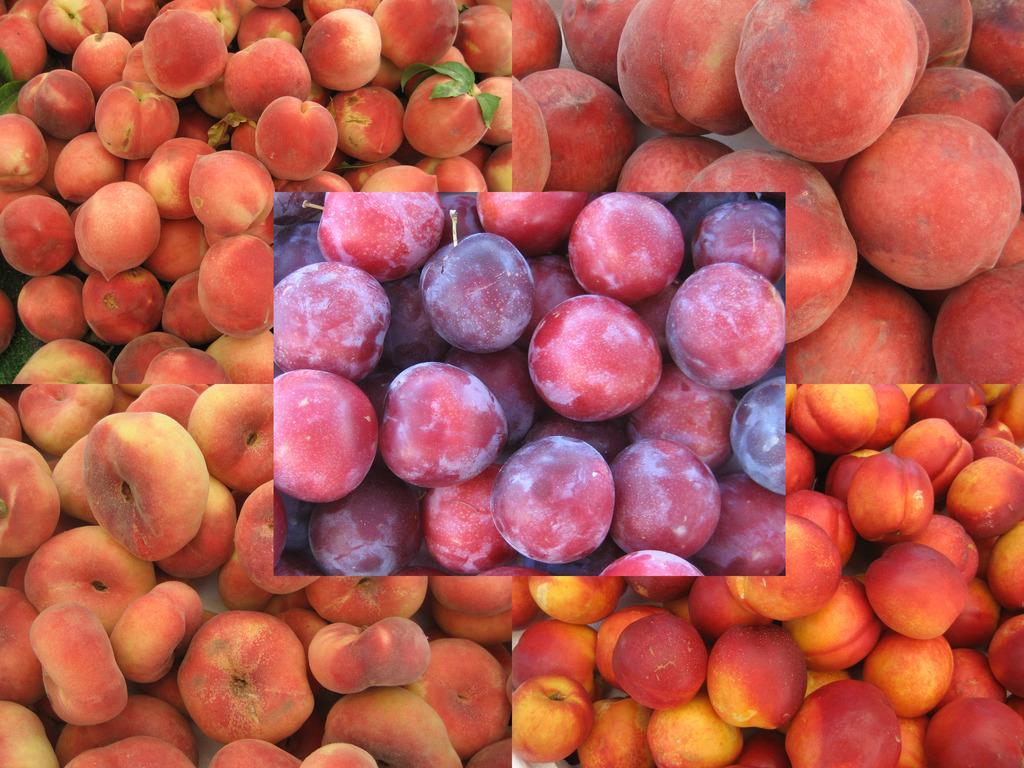In one or two sentences, can you explain what this image depicts? In this image we can see a collage picture of fruits. 